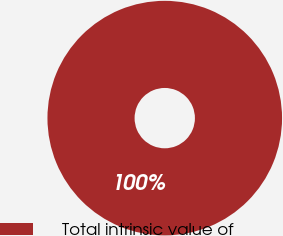<chart> <loc_0><loc_0><loc_500><loc_500><pie_chart><fcel>Total intrinsic value of<nl><fcel>100.0%<nl></chart> 